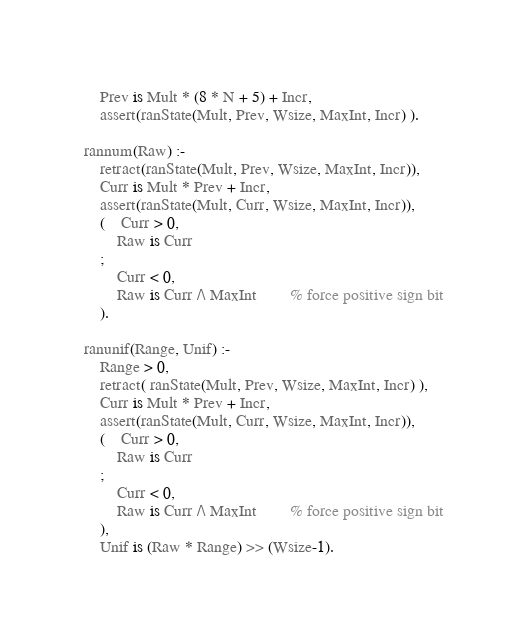<code> <loc_0><loc_0><loc_500><loc_500><_Prolog_>	Prev is Mult * (8 * N + 5) + Incr,
	assert(ranState(Mult, Prev, Wsize, MaxInt, Incr) ).
 
rannum(Raw) :-
	retract(ranState(Mult, Prev, Wsize, MaxInt, Incr)),
	Curr is Mult * Prev + Incr,
	assert(ranState(Mult, Curr, Wsize, MaxInt, Incr)),
	(	Curr > 0,
		Raw is Curr
	;
		Curr < 0,
		Raw is Curr /\ MaxInt		% force positive sign bit
	).
 
ranunif(Range, Unif) :-
	Range > 0,
	retract( ranState(Mult, Prev, Wsize, MaxInt, Incr) ),
	Curr is Mult * Prev + Incr,
	assert(ranState(Mult, Curr, Wsize, MaxInt, Incr)),
	(	Curr > 0,
		Raw is Curr
	;
		Curr < 0,
		Raw is Curr /\ MaxInt		% force positive sign bit
	),
	Unif is (Raw * Range) >> (Wsize-1).


</code> 